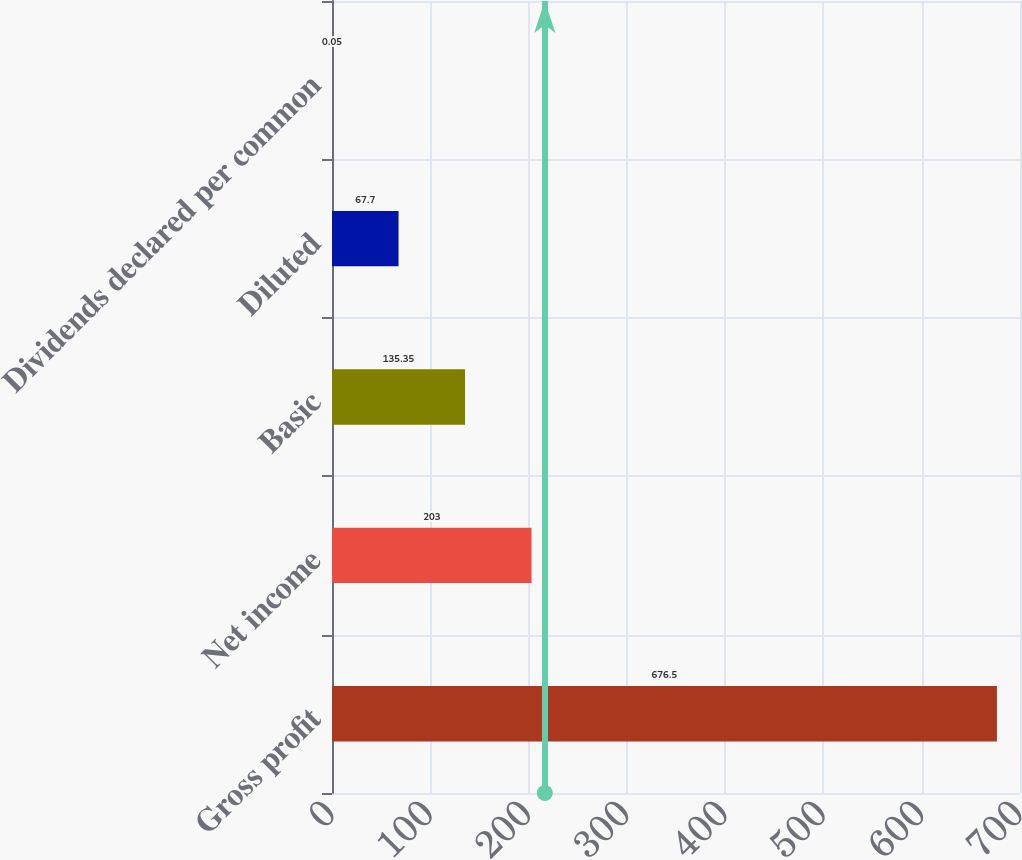<chart> <loc_0><loc_0><loc_500><loc_500><bar_chart><fcel>Gross profit<fcel>Net income<fcel>Basic<fcel>Diluted<fcel>Dividends declared per common<nl><fcel>676.5<fcel>203<fcel>135.35<fcel>67.7<fcel>0.05<nl></chart> 